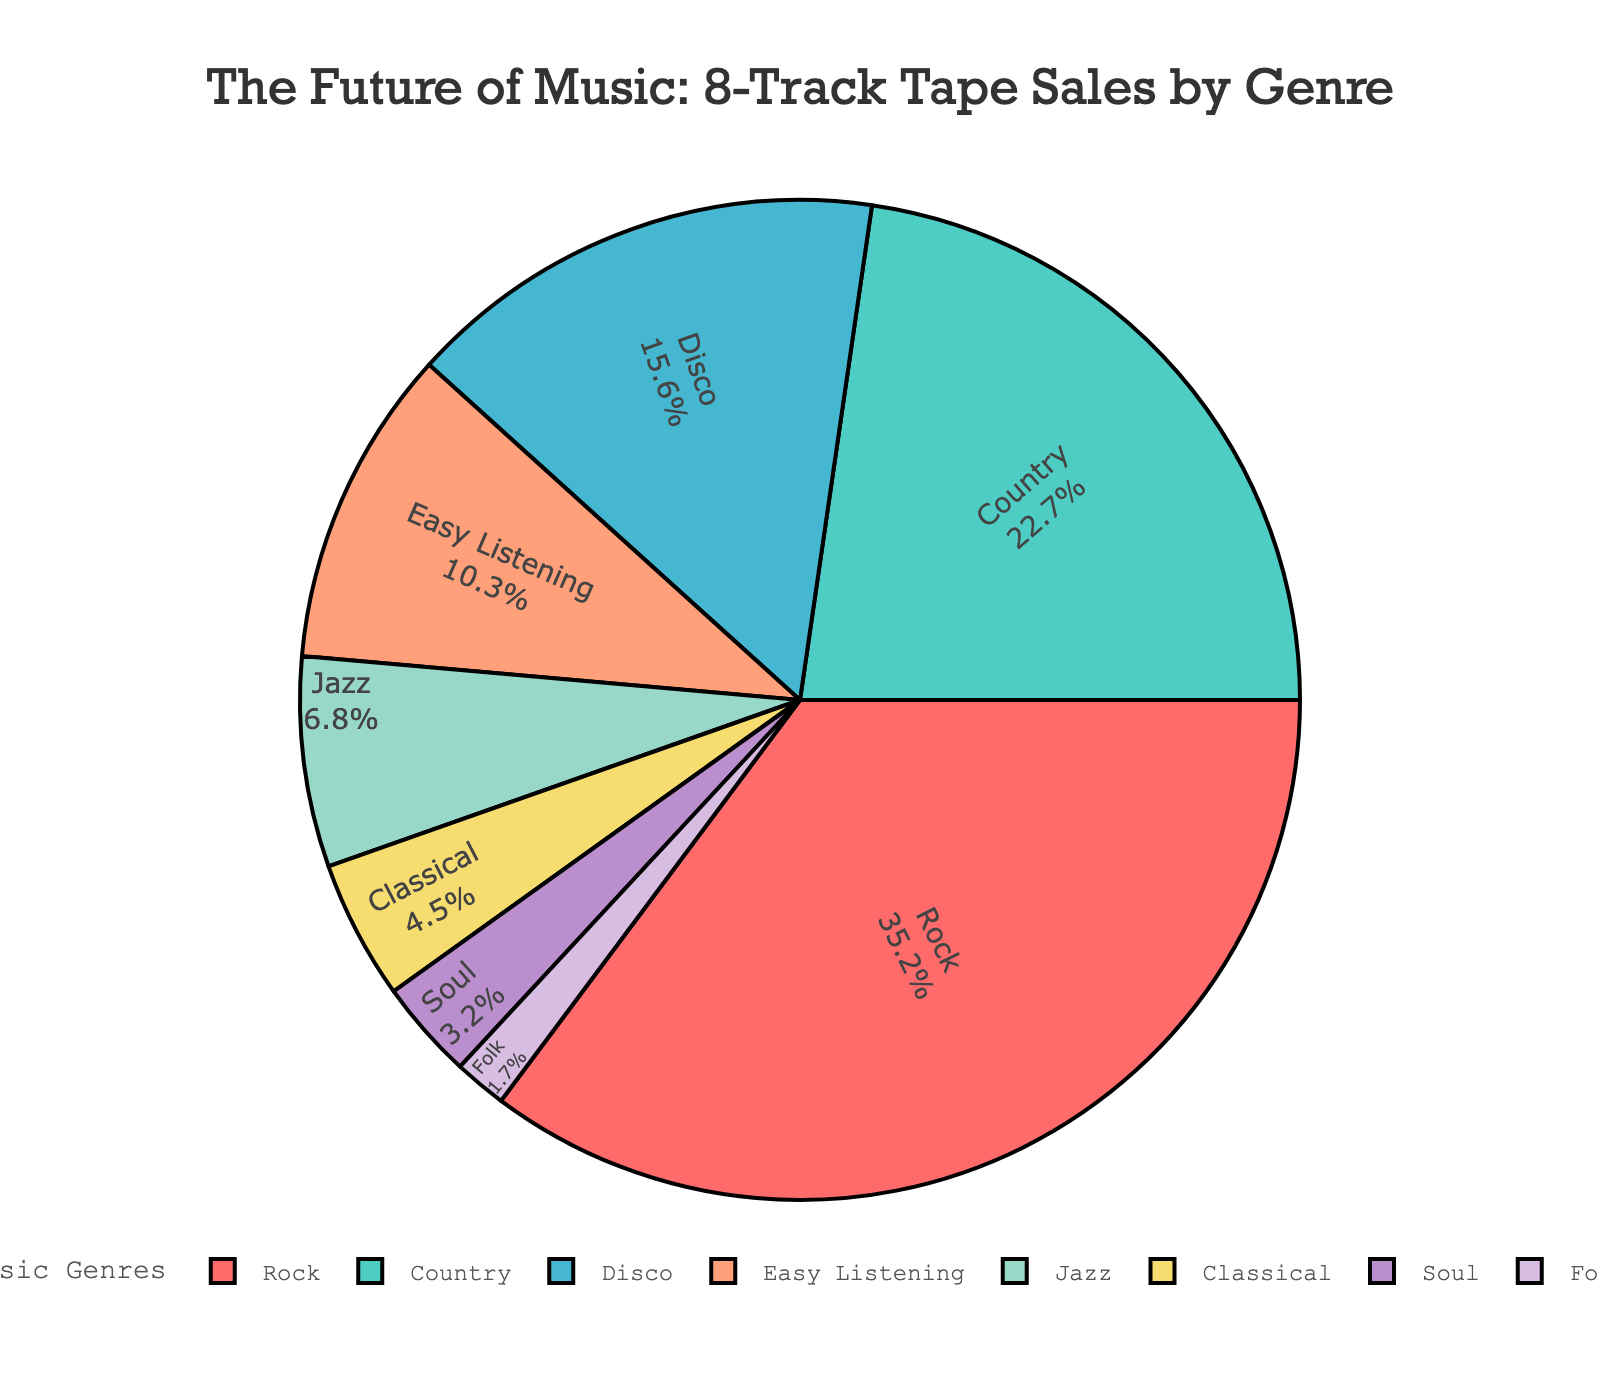What genre has the highest percentage in 8-track tape sales? The figure shows the percentage of sales for each genre in the pie chart. The genre with the largest slice has the highest percentage. Rock has the largest slice.
Answer: Rock Which genres combined make up more than 50% of 8-track tape sales? We need to add the percentages of the top genres until the sum exceeds 50%. Rock (35.2%) + Country (22.7%) = 57.9%.
Answer: Rock and Country What is the difference in sales percentage between Rock and Classical genres? Find the percentage of Rock sales and subtract the percentage of Classical sales. Difference = 35.2% - 4.5% = 30.7%.
Answer: 30.7% Which genre has the smallest percentage of 8-track tape sales, and what is that percentage? To find this, look for the smallest slice in the pie chart. Folk has the smallest percentage slice.
Answer: Folk, 1.7% Are there more sales of Disco 8-track tapes compared to Jazz 8-track tapes? Compare the percentages of Disco and Jazz. Disco has 15.6% and Jazz has 6.8%.
Answer: Yes, Disco has more sales How much more popular is Soul compared to Folk in terms of sales percentage? Subtract the percentage of Folk from the percentage of Soul. Difference = 3.2% - 1.7% = 1.5%.
Answer: 1.5% Which genres are represented visually by green and purple slices in the pie chart? Identify the slices by their color in the pie chart. Jazz is green and Classical is purple.
Answer: Jazz and Classical What percentage of sales comes from genres other than Rock, Country, and Disco combined? Subtract the combined percentage of Rock, Country, and Disco from 100%. Combined percentage of Rock, Country, and Disco = 35.2% + 22.7% + 15.6% = 73.5%. Other genres' percentage = 100% - 73.5% = 26.5%.
Answer: 26.5% Which genre is colored yellow in the pie chart? Identify the genre by matching the color of the slices. Easy Listening is colored yellow.
Answer: Easy Listening 